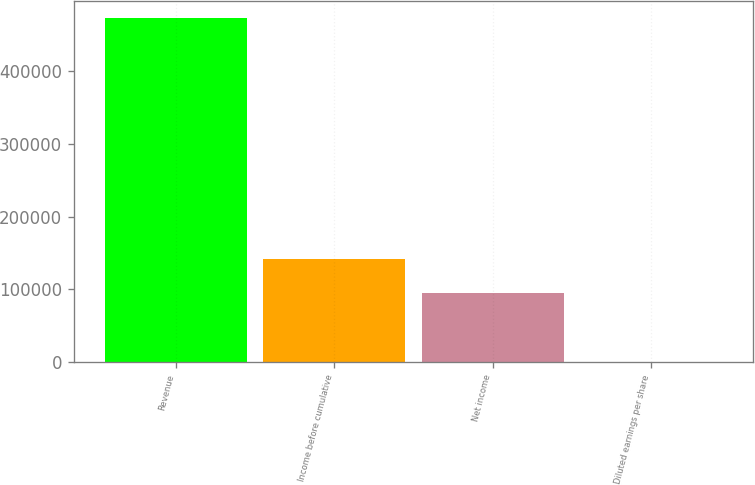Convert chart. <chart><loc_0><loc_0><loc_500><loc_500><bar_chart><fcel>Revenue<fcel>Income before cumulative<fcel>Net income<fcel>Diluted earnings per share<nl><fcel>473242<fcel>141973<fcel>94648.9<fcel>0.61<nl></chart> 